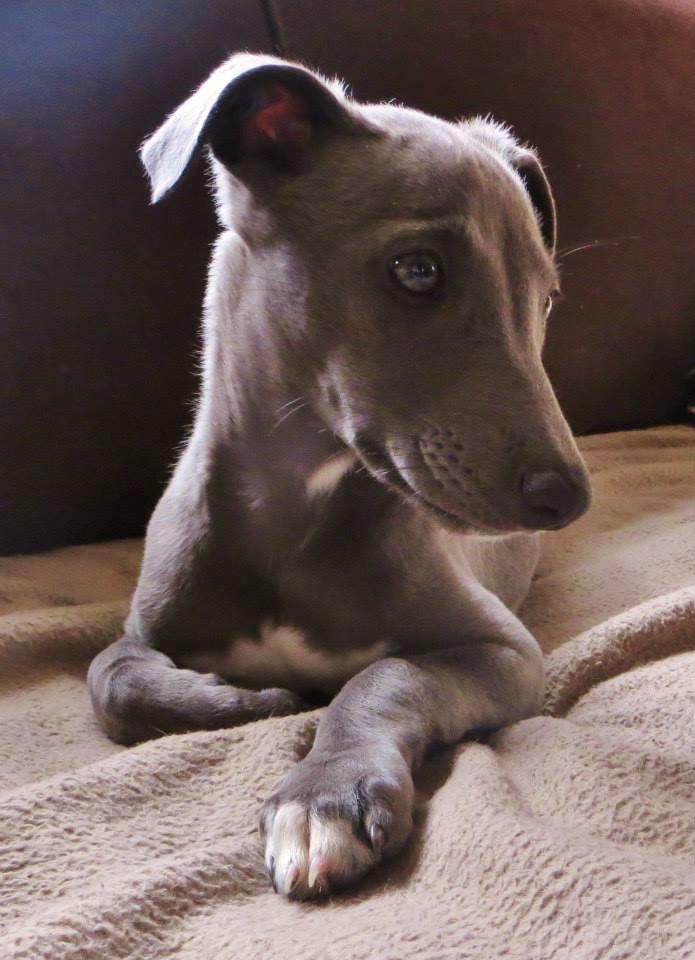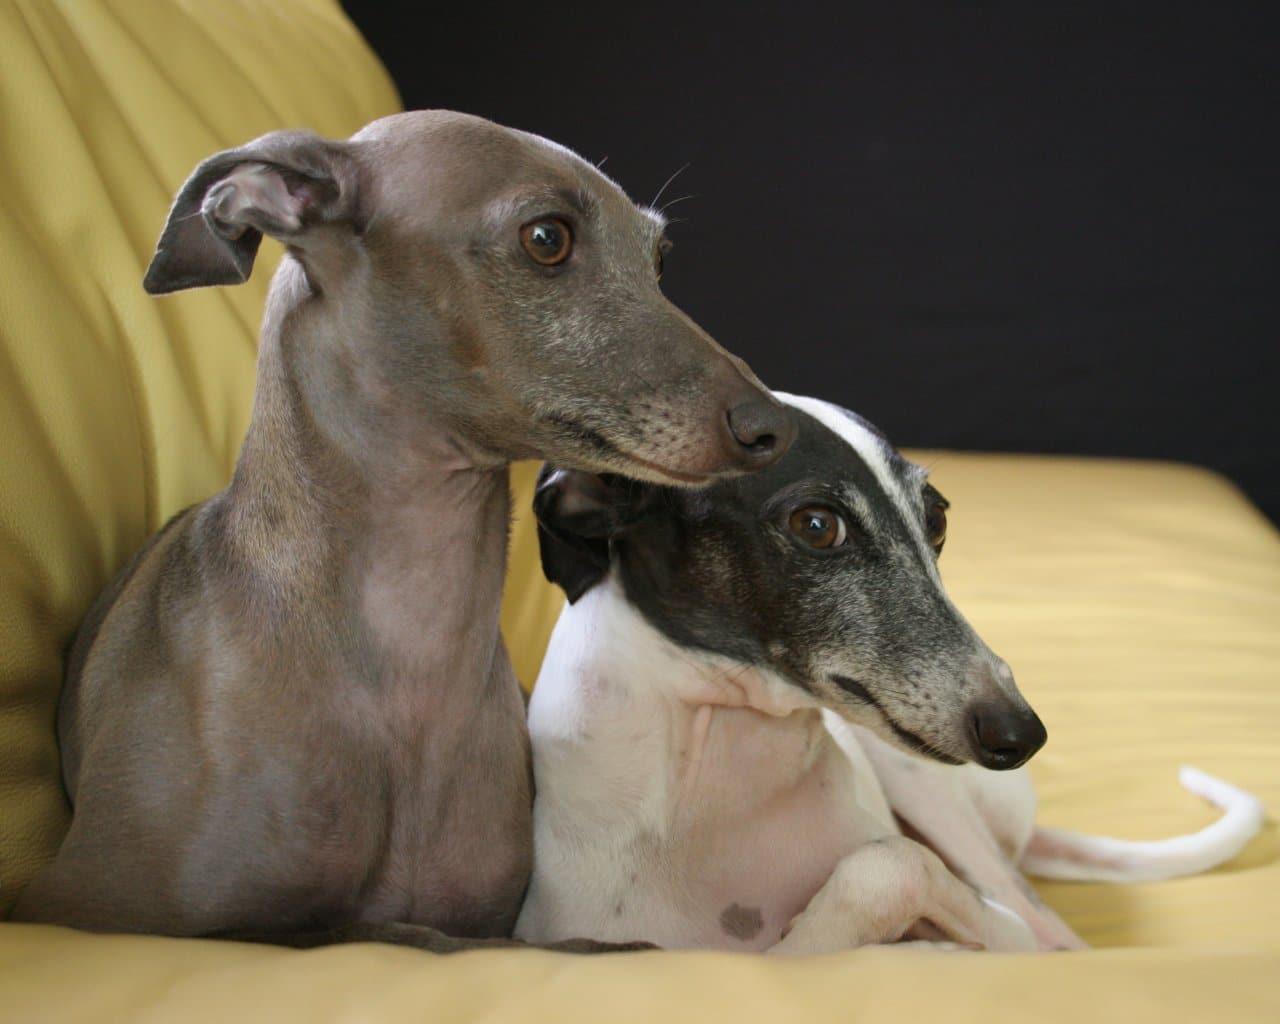The first image is the image on the left, the second image is the image on the right. Analyze the images presented: Is the assertion "Two dogs are sitting next to each other in the image on the right." valid? Answer yes or no. Yes. The first image is the image on the left, the second image is the image on the right. Analyze the images presented: Is the assertion "The right image contains twice as many hound dogs as the left image." valid? Answer yes or no. Yes. 